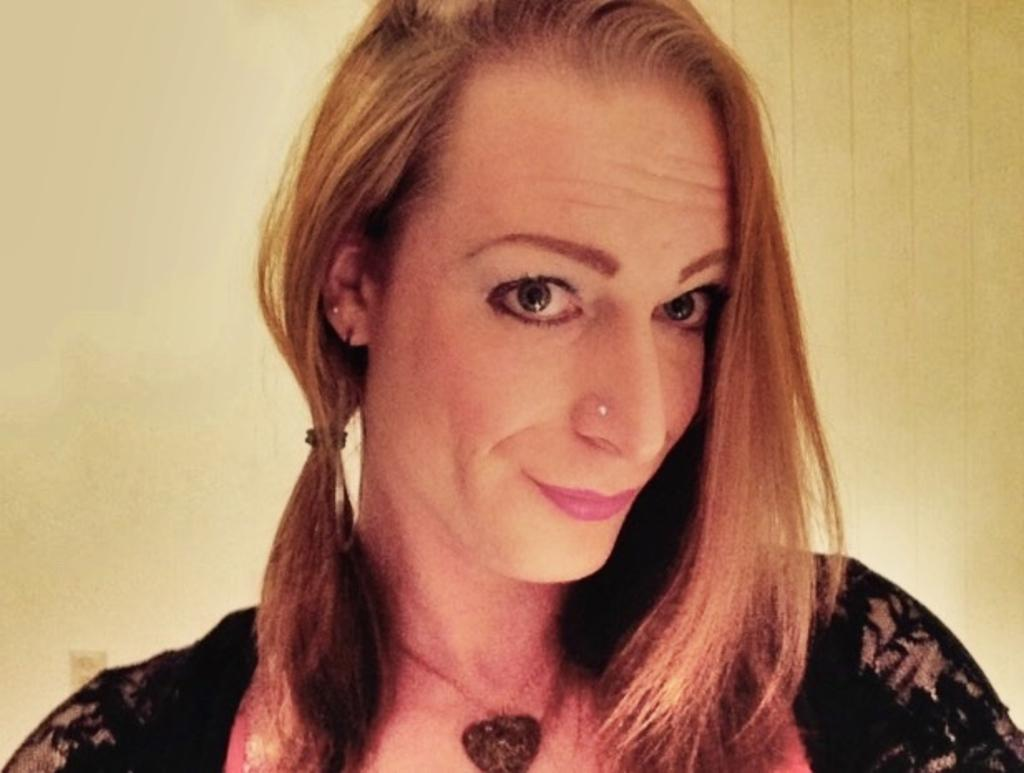Who is the main subject in the image? There is a woman in the image. What is the woman wearing? The woman is wearing a black dress. Are there any accessories visible on the woman? Yes, the woman is wearing a locket. What is the woman's facial expression? The woman is smiling. What can be seen in the background of the image? There is a wall visible in the background of the image. What type of metal is the bed made of in the image? There is no bed present in the image, so it is not possible to determine the type of metal used. 